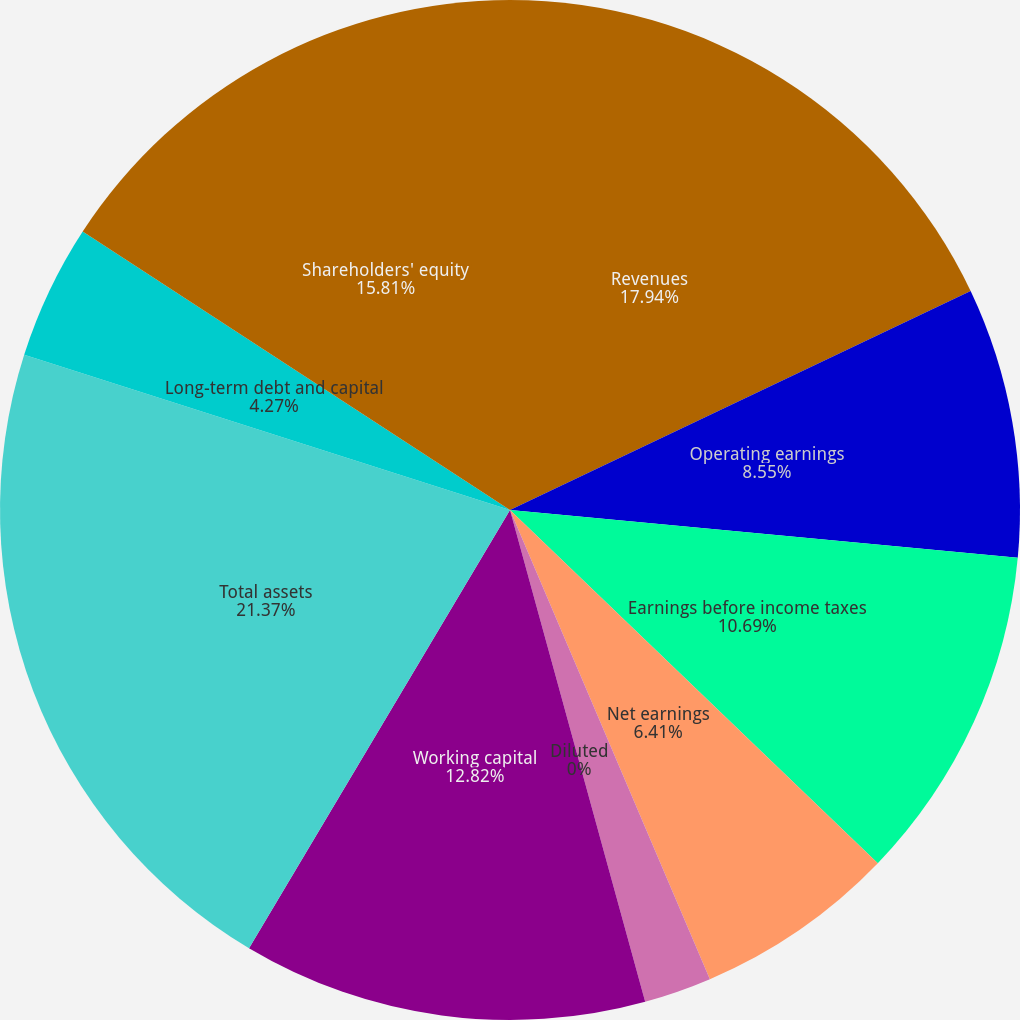Convert chart. <chart><loc_0><loc_0><loc_500><loc_500><pie_chart><fcel>Revenues<fcel>Operating earnings<fcel>Earnings before income taxes<fcel>Net earnings<fcel>Basic<fcel>Diluted<fcel>Working capital<fcel>Total assets<fcel>Long-term debt and capital<fcel>Shareholders' equity<nl><fcel>17.94%<fcel>8.55%<fcel>10.69%<fcel>6.41%<fcel>2.14%<fcel>0.0%<fcel>12.82%<fcel>21.37%<fcel>4.27%<fcel>15.81%<nl></chart> 